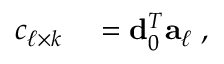<formula> <loc_0><loc_0><loc_500><loc_500>\begin{array} { r l } { c _ { \ell \times k } } & = { d } _ { 0 } ^ { T } { a } _ { \ell } \, , } \end{array}</formula> 